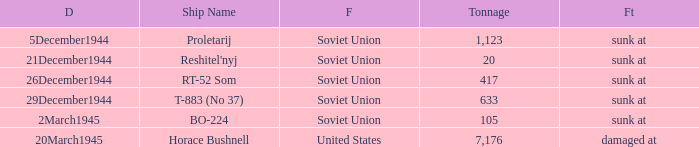Can you parse all the data within this table? {'header': ['D', 'Ship Name', 'F', 'Tonnage', 'Ft'], 'rows': [['5December1944', 'Proletarij', 'Soviet Union', '1,123', 'sunk at'], ['21December1944', "Reshitel'nyj", 'Soviet Union', '20', 'sunk at'], ['26December1944', 'RT-52 Som', 'Soviet Union', '417', 'sunk at'], ['29December1944', 'T-883 (No 37)', 'Soviet Union', '633', 'sunk at'], ['2March1945', 'BO-224', 'Soviet Union', '105', 'sunk at'], ['20March1945', 'Horace Bushnell', 'United States', '7,176', 'damaged at']]} What is the average tonnage of the ship named proletarij? 1123.0. 